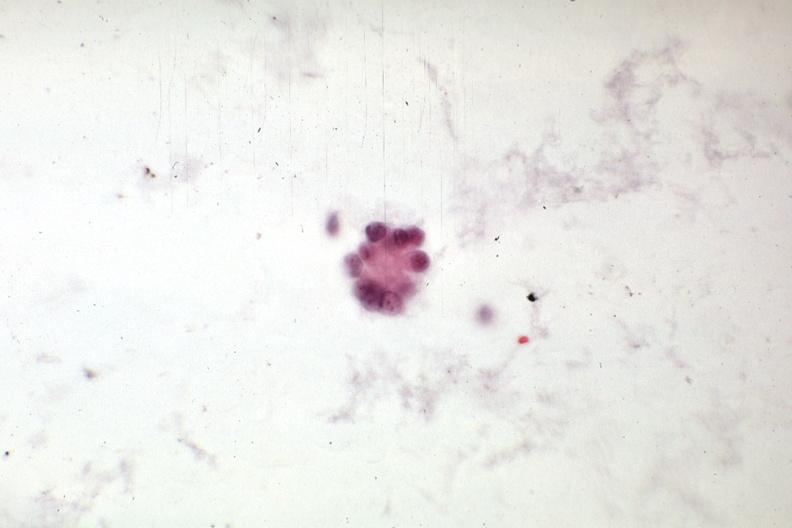s carcinoma present?
Answer the question using a single word or phrase. No 